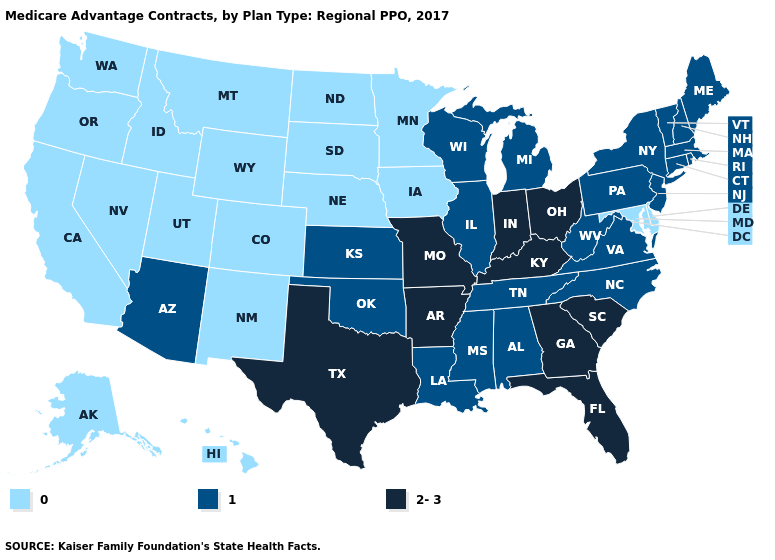What is the value of Georgia?
Answer briefly. 2-3. What is the lowest value in states that border Alabama?
Short answer required. 1. What is the highest value in states that border Maine?
Quick response, please. 1. What is the value of Tennessee?
Concise answer only. 1. Which states have the highest value in the USA?
Keep it brief. Arkansas, Florida, Georgia, Indiana, Kentucky, Missouri, Ohio, South Carolina, Texas. What is the value of North Carolina?
Concise answer only. 1. Name the states that have a value in the range 1?
Concise answer only. Alabama, Arizona, Connecticut, Illinois, Kansas, Louisiana, Massachusetts, Maine, Michigan, Mississippi, North Carolina, New Hampshire, New Jersey, New York, Oklahoma, Pennsylvania, Rhode Island, Tennessee, Virginia, Vermont, Wisconsin, West Virginia. Is the legend a continuous bar?
Give a very brief answer. No. Does Missouri have a higher value than Indiana?
Quick response, please. No. Which states hav the highest value in the West?
Short answer required. Arizona. What is the value of New Mexico?
Keep it brief. 0. Does Wisconsin have a lower value than South Carolina?
Give a very brief answer. Yes. Among the states that border South Carolina , which have the lowest value?
Quick response, please. North Carolina. 